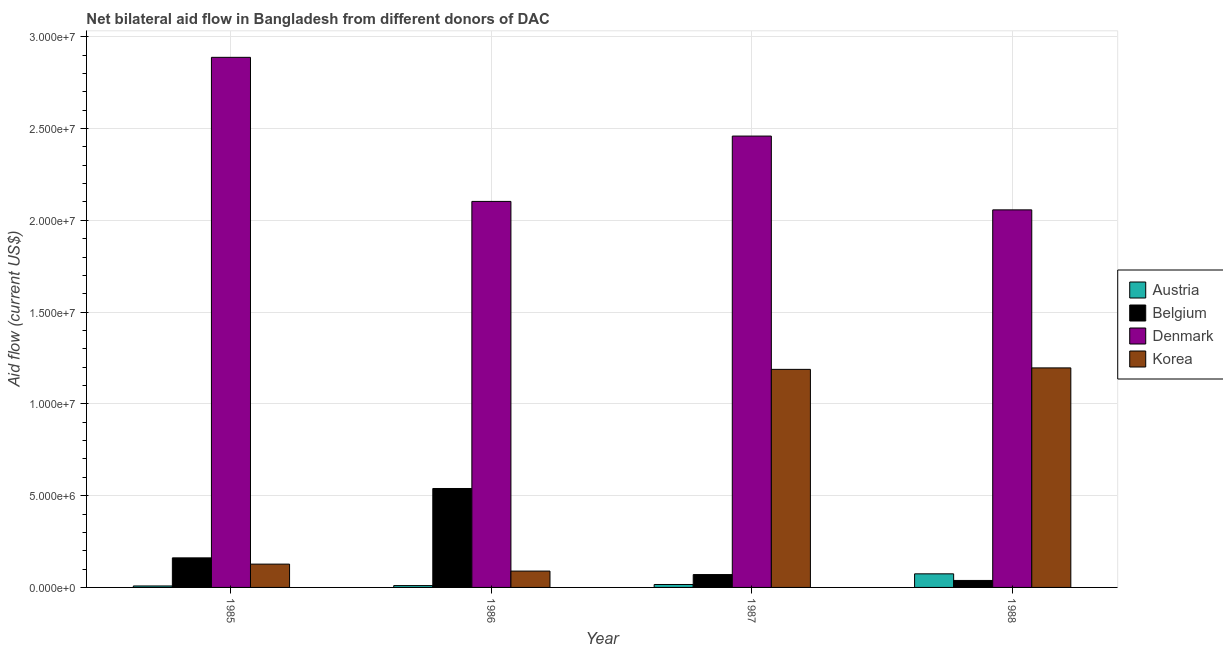Are the number of bars on each tick of the X-axis equal?
Give a very brief answer. Yes. How many bars are there on the 1st tick from the right?
Keep it short and to the point. 4. In how many cases, is the number of bars for a given year not equal to the number of legend labels?
Ensure brevity in your answer.  0. What is the amount of aid given by austria in 1986?
Offer a very short reply. 1.00e+05. Across all years, what is the maximum amount of aid given by belgium?
Keep it short and to the point. 5.39e+06. Across all years, what is the minimum amount of aid given by belgium?
Your answer should be very brief. 3.80e+05. In which year was the amount of aid given by belgium minimum?
Keep it short and to the point. 1988. What is the total amount of aid given by belgium in the graph?
Offer a terse response. 8.08e+06. What is the difference between the amount of aid given by korea in 1986 and that in 1987?
Your answer should be compact. -1.10e+07. What is the difference between the amount of aid given by denmark in 1985 and the amount of aid given by korea in 1987?
Your response must be concise. 4.29e+06. What is the average amount of aid given by korea per year?
Provide a succinct answer. 6.50e+06. What is the ratio of the amount of aid given by korea in 1985 to that in 1986?
Your answer should be very brief. 1.43. Is the difference between the amount of aid given by belgium in 1986 and 1987 greater than the difference between the amount of aid given by austria in 1986 and 1987?
Your answer should be very brief. No. What is the difference between the highest and the lowest amount of aid given by belgium?
Your answer should be compact. 5.01e+06. What does the 3rd bar from the left in 1985 represents?
Provide a short and direct response. Denmark. How many bars are there?
Your answer should be compact. 16. Are all the bars in the graph horizontal?
Offer a terse response. No. Are the values on the major ticks of Y-axis written in scientific E-notation?
Keep it short and to the point. Yes. Does the graph contain any zero values?
Keep it short and to the point. No. Does the graph contain grids?
Provide a succinct answer. Yes. How are the legend labels stacked?
Your answer should be very brief. Vertical. What is the title of the graph?
Keep it short and to the point. Net bilateral aid flow in Bangladesh from different donors of DAC. What is the Aid flow (current US$) of Belgium in 1985?
Keep it short and to the point. 1.61e+06. What is the Aid flow (current US$) of Denmark in 1985?
Offer a very short reply. 2.89e+07. What is the Aid flow (current US$) in Korea in 1985?
Your answer should be very brief. 1.27e+06. What is the Aid flow (current US$) in Belgium in 1986?
Your response must be concise. 5.39e+06. What is the Aid flow (current US$) of Denmark in 1986?
Your response must be concise. 2.10e+07. What is the Aid flow (current US$) of Korea in 1986?
Offer a terse response. 8.90e+05. What is the Aid flow (current US$) in Austria in 1987?
Offer a very short reply. 1.60e+05. What is the Aid flow (current US$) in Denmark in 1987?
Your response must be concise. 2.46e+07. What is the Aid flow (current US$) in Korea in 1987?
Your response must be concise. 1.19e+07. What is the Aid flow (current US$) in Austria in 1988?
Give a very brief answer. 7.40e+05. What is the Aid flow (current US$) in Denmark in 1988?
Make the answer very short. 2.06e+07. What is the Aid flow (current US$) of Korea in 1988?
Provide a succinct answer. 1.20e+07. Across all years, what is the maximum Aid flow (current US$) in Austria?
Keep it short and to the point. 7.40e+05. Across all years, what is the maximum Aid flow (current US$) of Belgium?
Your answer should be very brief. 5.39e+06. Across all years, what is the maximum Aid flow (current US$) in Denmark?
Your response must be concise. 2.89e+07. Across all years, what is the maximum Aid flow (current US$) in Korea?
Provide a short and direct response. 1.20e+07. Across all years, what is the minimum Aid flow (current US$) in Austria?
Make the answer very short. 8.00e+04. Across all years, what is the minimum Aid flow (current US$) in Denmark?
Provide a short and direct response. 2.06e+07. Across all years, what is the minimum Aid flow (current US$) in Korea?
Give a very brief answer. 8.90e+05. What is the total Aid flow (current US$) of Austria in the graph?
Make the answer very short. 1.08e+06. What is the total Aid flow (current US$) of Belgium in the graph?
Ensure brevity in your answer.  8.08e+06. What is the total Aid flow (current US$) in Denmark in the graph?
Your answer should be compact. 9.51e+07. What is the total Aid flow (current US$) in Korea in the graph?
Keep it short and to the point. 2.60e+07. What is the difference between the Aid flow (current US$) in Belgium in 1985 and that in 1986?
Offer a terse response. -3.78e+06. What is the difference between the Aid flow (current US$) of Denmark in 1985 and that in 1986?
Your response must be concise. 7.85e+06. What is the difference between the Aid flow (current US$) of Austria in 1985 and that in 1987?
Make the answer very short. -8.00e+04. What is the difference between the Aid flow (current US$) in Belgium in 1985 and that in 1987?
Provide a short and direct response. 9.10e+05. What is the difference between the Aid flow (current US$) in Denmark in 1985 and that in 1987?
Keep it short and to the point. 4.29e+06. What is the difference between the Aid flow (current US$) in Korea in 1985 and that in 1987?
Keep it short and to the point. -1.06e+07. What is the difference between the Aid flow (current US$) in Austria in 1985 and that in 1988?
Offer a terse response. -6.60e+05. What is the difference between the Aid flow (current US$) of Belgium in 1985 and that in 1988?
Give a very brief answer. 1.23e+06. What is the difference between the Aid flow (current US$) of Denmark in 1985 and that in 1988?
Offer a terse response. 8.31e+06. What is the difference between the Aid flow (current US$) of Korea in 1985 and that in 1988?
Offer a very short reply. -1.07e+07. What is the difference between the Aid flow (current US$) in Belgium in 1986 and that in 1987?
Ensure brevity in your answer.  4.69e+06. What is the difference between the Aid flow (current US$) of Denmark in 1986 and that in 1987?
Offer a very short reply. -3.56e+06. What is the difference between the Aid flow (current US$) in Korea in 1986 and that in 1987?
Offer a terse response. -1.10e+07. What is the difference between the Aid flow (current US$) in Austria in 1986 and that in 1988?
Provide a short and direct response. -6.40e+05. What is the difference between the Aid flow (current US$) of Belgium in 1986 and that in 1988?
Offer a terse response. 5.01e+06. What is the difference between the Aid flow (current US$) in Korea in 1986 and that in 1988?
Ensure brevity in your answer.  -1.11e+07. What is the difference between the Aid flow (current US$) of Austria in 1987 and that in 1988?
Provide a succinct answer. -5.80e+05. What is the difference between the Aid flow (current US$) of Belgium in 1987 and that in 1988?
Your answer should be compact. 3.20e+05. What is the difference between the Aid flow (current US$) in Denmark in 1987 and that in 1988?
Make the answer very short. 4.02e+06. What is the difference between the Aid flow (current US$) of Austria in 1985 and the Aid flow (current US$) of Belgium in 1986?
Give a very brief answer. -5.31e+06. What is the difference between the Aid flow (current US$) in Austria in 1985 and the Aid flow (current US$) in Denmark in 1986?
Your response must be concise. -2.10e+07. What is the difference between the Aid flow (current US$) in Austria in 1985 and the Aid flow (current US$) in Korea in 1986?
Provide a short and direct response. -8.10e+05. What is the difference between the Aid flow (current US$) of Belgium in 1985 and the Aid flow (current US$) of Denmark in 1986?
Offer a terse response. -1.94e+07. What is the difference between the Aid flow (current US$) in Belgium in 1985 and the Aid flow (current US$) in Korea in 1986?
Provide a short and direct response. 7.20e+05. What is the difference between the Aid flow (current US$) in Denmark in 1985 and the Aid flow (current US$) in Korea in 1986?
Ensure brevity in your answer.  2.80e+07. What is the difference between the Aid flow (current US$) of Austria in 1985 and the Aid flow (current US$) of Belgium in 1987?
Offer a terse response. -6.20e+05. What is the difference between the Aid flow (current US$) in Austria in 1985 and the Aid flow (current US$) in Denmark in 1987?
Give a very brief answer. -2.45e+07. What is the difference between the Aid flow (current US$) in Austria in 1985 and the Aid flow (current US$) in Korea in 1987?
Make the answer very short. -1.18e+07. What is the difference between the Aid flow (current US$) of Belgium in 1985 and the Aid flow (current US$) of Denmark in 1987?
Offer a terse response. -2.30e+07. What is the difference between the Aid flow (current US$) of Belgium in 1985 and the Aid flow (current US$) of Korea in 1987?
Offer a very short reply. -1.03e+07. What is the difference between the Aid flow (current US$) of Denmark in 1985 and the Aid flow (current US$) of Korea in 1987?
Your answer should be compact. 1.70e+07. What is the difference between the Aid flow (current US$) in Austria in 1985 and the Aid flow (current US$) in Belgium in 1988?
Make the answer very short. -3.00e+05. What is the difference between the Aid flow (current US$) of Austria in 1985 and the Aid flow (current US$) of Denmark in 1988?
Ensure brevity in your answer.  -2.05e+07. What is the difference between the Aid flow (current US$) of Austria in 1985 and the Aid flow (current US$) of Korea in 1988?
Provide a succinct answer. -1.19e+07. What is the difference between the Aid flow (current US$) in Belgium in 1985 and the Aid flow (current US$) in Denmark in 1988?
Your response must be concise. -1.90e+07. What is the difference between the Aid flow (current US$) in Belgium in 1985 and the Aid flow (current US$) in Korea in 1988?
Offer a very short reply. -1.04e+07. What is the difference between the Aid flow (current US$) of Denmark in 1985 and the Aid flow (current US$) of Korea in 1988?
Your answer should be very brief. 1.69e+07. What is the difference between the Aid flow (current US$) of Austria in 1986 and the Aid flow (current US$) of Belgium in 1987?
Keep it short and to the point. -6.00e+05. What is the difference between the Aid flow (current US$) in Austria in 1986 and the Aid flow (current US$) in Denmark in 1987?
Keep it short and to the point. -2.45e+07. What is the difference between the Aid flow (current US$) in Austria in 1986 and the Aid flow (current US$) in Korea in 1987?
Your answer should be compact. -1.18e+07. What is the difference between the Aid flow (current US$) of Belgium in 1986 and the Aid flow (current US$) of Denmark in 1987?
Offer a terse response. -1.92e+07. What is the difference between the Aid flow (current US$) in Belgium in 1986 and the Aid flow (current US$) in Korea in 1987?
Offer a terse response. -6.49e+06. What is the difference between the Aid flow (current US$) of Denmark in 1986 and the Aid flow (current US$) of Korea in 1987?
Offer a very short reply. 9.15e+06. What is the difference between the Aid flow (current US$) in Austria in 1986 and the Aid flow (current US$) in Belgium in 1988?
Provide a short and direct response. -2.80e+05. What is the difference between the Aid flow (current US$) in Austria in 1986 and the Aid flow (current US$) in Denmark in 1988?
Offer a very short reply. -2.05e+07. What is the difference between the Aid flow (current US$) of Austria in 1986 and the Aid flow (current US$) of Korea in 1988?
Ensure brevity in your answer.  -1.19e+07. What is the difference between the Aid flow (current US$) of Belgium in 1986 and the Aid flow (current US$) of Denmark in 1988?
Your response must be concise. -1.52e+07. What is the difference between the Aid flow (current US$) of Belgium in 1986 and the Aid flow (current US$) of Korea in 1988?
Provide a succinct answer. -6.57e+06. What is the difference between the Aid flow (current US$) in Denmark in 1986 and the Aid flow (current US$) in Korea in 1988?
Your response must be concise. 9.07e+06. What is the difference between the Aid flow (current US$) of Austria in 1987 and the Aid flow (current US$) of Belgium in 1988?
Make the answer very short. -2.20e+05. What is the difference between the Aid flow (current US$) of Austria in 1987 and the Aid flow (current US$) of Denmark in 1988?
Ensure brevity in your answer.  -2.04e+07. What is the difference between the Aid flow (current US$) in Austria in 1987 and the Aid flow (current US$) in Korea in 1988?
Keep it short and to the point. -1.18e+07. What is the difference between the Aid flow (current US$) in Belgium in 1987 and the Aid flow (current US$) in Denmark in 1988?
Your answer should be very brief. -1.99e+07. What is the difference between the Aid flow (current US$) in Belgium in 1987 and the Aid flow (current US$) in Korea in 1988?
Your response must be concise. -1.13e+07. What is the difference between the Aid flow (current US$) in Denmark in 1987 and the Aid flow (current US$) in Korea in 1988?
Ensure brevity in your answer.  1.26e+07. What is the average Aid flow (current US$) in Austria per year?
Your response must be concise. 2.70e+05. What is the average Aid flow (current US$) in Belgium per year?
Provide a short and direct response. 2.02e+06. What is the average Aid flow (current US$) in Denmark per year?
Offer a very short reply. 2.38e+07. What is the average Aid flow (current US$) in Korea per year?
Give a very brief answer. 6.50e+06. In the year 1985, what is the difference between the Aid flow (current US$) of Austria and Aid flow (current US$) of Belgium?
Your answer should be very brief. -1.53e+06. In the year 1985, what is the difference between the Aid flow (current US$) of Austria and Aid flow (current US$) of Denmark?
Give a very brief answer. -2.88e+07. In the year 1985, what is the difference between the Aid flow (current US$) in Austria and Aid flow (current US$) in Korea?
Keep it short and to the point. -1.19e+06. In the year 1985, what is the difference between the Aid flow (current US$) of Belgium and Aid flow (current US$) of Denmark?
Your answer should be very brief. -2.73e+07. In the year 1985, what is the difference between the Aid flow (current US$) of Belgium and Aid flow (current US$) of Korea?
Offer a terse response. 3.40e+05. In the year 1985, what is the difference between the Aid flow (current US$) in Denmark and Aid flow (current US$) in Korea?
Your answer should be very brief. 2.76e+07. In the year 1986, what is the difference between the Aid flow (current US$) in Austria and Aid flow (current US$) in Belgium?
Your answer should be compact. -5.29e+06. In the year 1986, what is the difference between the Aid flow (current US$) in Austria and Aid flow (current US$) in Denmark?
Provide a succinct answer. -2.09e+07. In the year 1986, what is the difference between the Aid flow (current US$) of Austria and Aid flow (current US$) of Korea?
Keep it short and to the point. -7.90e+05. In the year 1986, what is the difference between the Aid flow (current US$) of Belgium and Aid flow (current US$) of Denmark?
Your answer should be compact. -1.56e+07. In the year 1986, what is the difference between the Aid flow (current US$) of Belgium and Aid flow (current US$) of Korea?
Make the answer very short. 4.50e+06. In the year 1986, what is the difference between the Aid flow (current US$) of Denmark and Aid flow (current US$) of Korea?
Offer a very short reply. 2.01e+07. In the year 1987, what is the difference between the Aid flow (current US$) of Austria and Aid flow (current US$) of Belgium?
Provide a short and direct response. -5.40e+05. In the year 1987, what is the difference between the Aid flow (current US$) in Austria and Aid flow (current US$) in Denmark?
Provide a short and direct response. -2.44e+07. In the year 1987, what is the difference between the Aid flow (current US$) in Austria and Aid flow (current US$) in Korea?
Ensure brevity in your answer.  -1.17e+07. In the year 1987, what is the difference between the Aid flow (current US$) in Belgium and Aid flow (current US$) in Denmark?
Offer a terse response. -2.39e+07. In the year 1987, what is the difference between the Aid flow (current US$) in Belgium and Aid flow (current US$) in Korea?
Give a very brief answer. -1.12e+07. In the year 1987, what is the difference between the Aid flow (current US$) of Denmark and Aid flow (current US$) of Korea?
Your response must be concise. 1.27e+07. In the year 1988, what is the difference between the Aid flow (current US$) in Austria and Aid flow (current US$) in Denmark?
Provide a short and direct response. -1.98e+07. In the year 1988, what is the difference between the Aid flow (current US$) in Austria and Aid flow (current US$) in Korea?
Provide a short and direct response. -1.12e+07. In the year 1988, what is the difference between the Aid flow (current US$) of Belgium and Aid flow (current US$) of Denmark?
Make the answer very short. -2.02e+07. In the year 1988, what is the difference between the Aid flow (current US$) of Belgium and Aid flow (current US$) of Korea?
Make the answer very short. -1.16e+07. In the year 1988, what is the difference between the Aid flow (current US$) of Denmark and Aid flow (current US$) of Korea?
Provide a succinct answer. 8.61e+06. What is the ratio of the Aid flow (current US$) of Belgium in 1985 to that in 1986?
Offer a very short reply. 0.3. What is the ratio of the Aid flow (current US$) of Denmark in 1985 to that in 1986?
Offer a very short reply. 1.37. What is the ratio of the Aid flow (current US$) of Korea in 1985 to that in 1986?
Offer a very short reply. 1.43. What is the ratio of the Aid flow (current US$) of Austria in 1985 to that in 1987?
Ensure brevity in your answer.  0.5. What is the ratio of the Aid flow (current US$) in Belgium in 1985 to that in 1987?
Provide a short and direct response. 2.3. What is the ratio of the Aid flow (current US$) in Denmark in 1985 to that in 1987?
Provide a short and direct response. 1.17. What is the ratio of the Aid flow (current US$) in Korea in 1985 to that in 1987?
Provide a short and direct response. 0.11. What is the ratio of the Aid flow (current US$) in Austria in 1985 to that in 1988?
Provide a short and direct response. 0.11. What is the ratio of the Aid flow (current US$) in Belgium in 1985 to that in 1988?
Provide a short and direct response. 4.24. What is the ratio of the Aid flow (current US$) of Denmark in 1985 to that in 1988?
Provide a succinct answer. 1.4. What is the ratio of the Aid flow (current US$) of Korea in 1985 to that in 1988?
Offer a very short reply. 0.11. What is the ratio of the Aid flow (current US$) of Austria in 1986 to that in 1987?
Keep it short and to the point. 0.62. What is the ratio of the Aid flow (current US$) in Denmark in 1986 to that in 1987?
Give a very brief answer. 0.86. What is the ratio of the Aid flow (current US$) in Korea in 1986 to that in 1987?
Provide a succinct answer. 0.07. What is the ratio of the Aid flow (current US$) in Austria in 1986 to that in 1988?
Keep it short and to the point. 0.14. What is the ratio of the Aid flow (current US$) of Belgium in 1986 to that in 1988?
Provide a short and direct response. 14.18. What is the ratio of the Aid flow (current US$) of Denmark in 1986 to that in 1988?
Your answer should be very brief. 1.02. What is the ratio of the Aid flow (current US$) of Korea in 1986 to that in 1988?
Your response must be concise. 0.07. What is the ratio of the Aid flow (current US$) in Austria in 1987 to that in 1988?
Your answer should be very brief. 0.22. What is the ratio of the Aid flow (current US$) of Belgium in 1987 to that in 1988?
Provide a succinct answer. 1.84. What is the ratio of the Aid flow (current US$) in Denmark in 1987 to that in 1988?
Offer a terse response. 1.2. What is the ratio of the Aid flow (current US$) of Korea in 1987 to that in 1988?
Your answer should be compact. 0.99. What is the difference between the highest and the second highest Aid flow (current US$) of Austria?
Provide a succinct answer. 5.80e+05. What is the difference between the highest and the second highest Aid flow (current US$) of Belgium?
Provide a short and direct response. 3.78e+06. What is the difference between the highest and the second highest Aid flow (current US$) of Denmark?
Offer a very short reply. 4.29e+06. What is the difference between the highest and the second highest Aid flow (current US$) of Korea?
Offer a terse response. 8.00e+04. What is the difference between the highest and the lowest Aid flow (current US$) of Austria?
Give a very brief answer. 6.60e+05. What is the difference between the highest and the lowest Aid flow (current US$) in Belgium?
Offer a terse response. 5.01e+06. What is the difference between the highest and the lowest Aid flow (current US$) in Denmark?
Make the answer very short. 8.31e+06. What is the difference between the highest and the lowest Aid flow (current US$) in Korea?
Your response must be concise. 1.11e+07. 